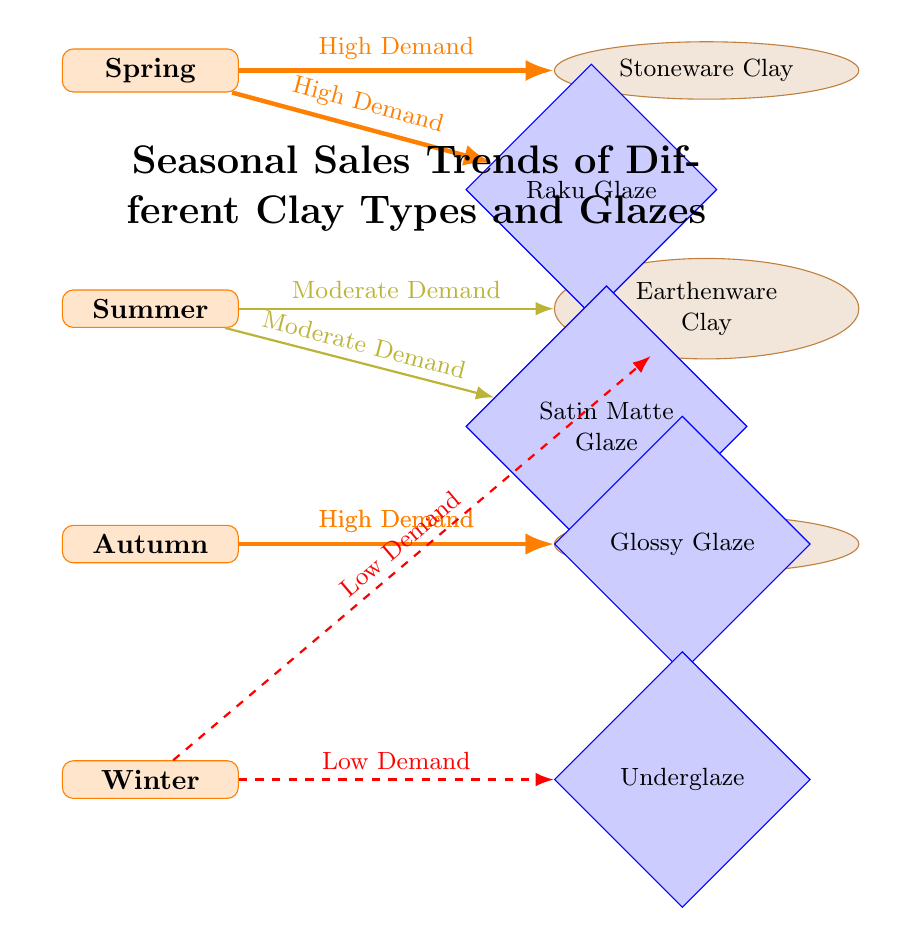What clay type has high demand in spring? The edge from the spring node indicates that Stoneware Clay has high demand during that season.
Answer: Stoneware Clay What glaze type has moderate demand in summer? The edge from the summer node shows that Satin Matte Glaze is associated with moderate demand in that season.
Answer: Satin Matte Glaze How many types of clay are represented in the diagram? By counting the clay nodes, we find there are three types: Stoneware Clay, Earthenware Clay, and Porcelain Clay.
Answer: 3 What season has the lowest demand for earthenware? The diagram indicates that in winter, the edge connecting winter to earthenware is dashed, indicating low demand.
Answer: Winter Which glaze type shows high demand in autumn? The edge from the autumn node points to Glossy Glaze, indicating it has high demand in that season.
Answer: Glossy Glaze What is the relationship between spring and Raku Glaze? Both spring and Raku Glaze are connected by a solid orange edge describing a high demand relationship.
Answer: High Demand Which season has the highest overall demand for clay types? The edges indicate that both spring and autumn have high demand for specific clay types, but spring specifically has high demand for Stoneware Clay and Raku.
Answer: Spring Which clay type is least in demand during winter? The edge shows that Earthenware Clay has low demand in winter, as indicated by the dashed red line.
Answer: Earthenware Clay What is the total number of connections (edges) in the diagram? Counting all the edges shows there are a total of six connections representing the demand relationships.
Answer: 6 